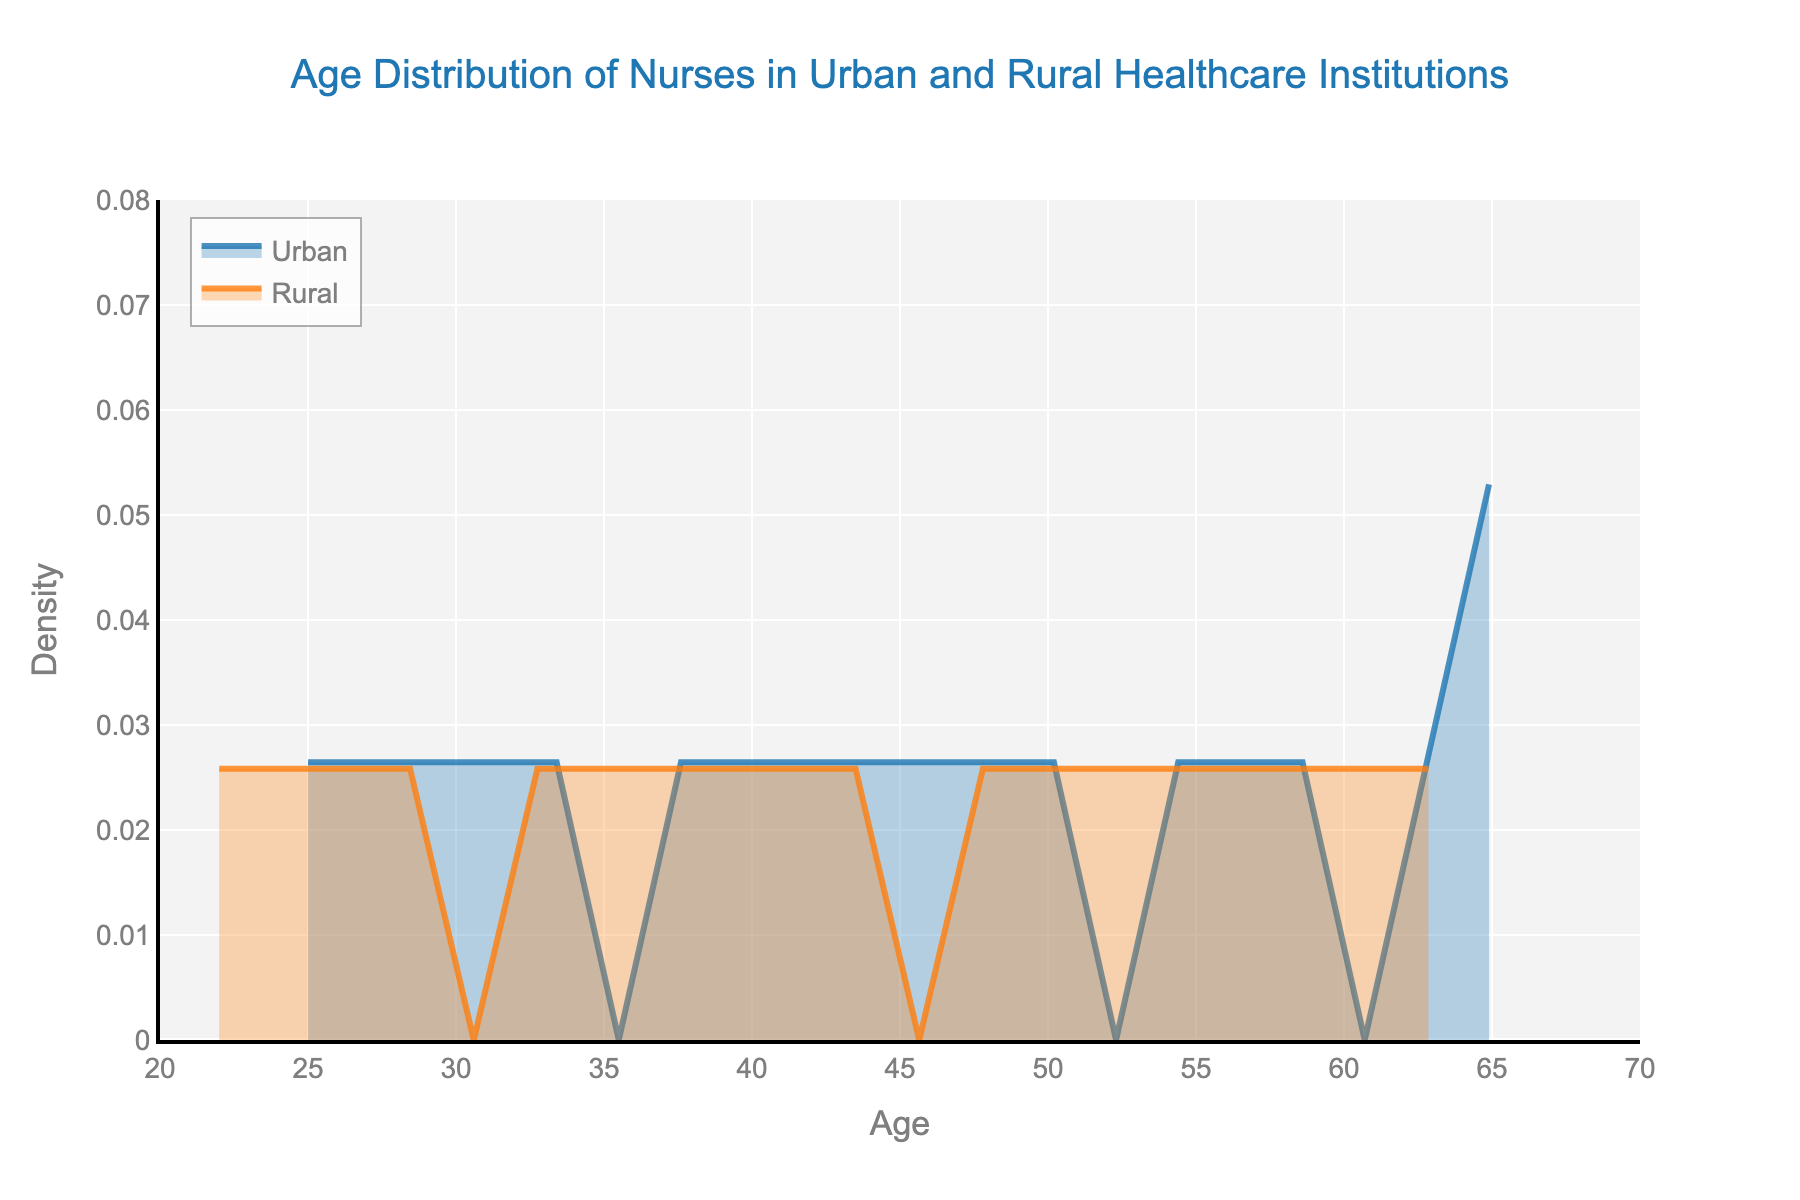What's the title of the figure? The title is usually found at the top of the figure. In this case, it reads "Age Distribution of Nurses in Urban and Rural Healthcare Institutions."
Answer: Age Distribution of Nurses in Urban and Rural Healthcare Institutions What is the range of ages displayed on the x-axis of the figure? The age range on the x-axis is specified by the axis ticks. Here, it ranges from 20 to 70 years.
Answer: 20 to 70 years What age group has the most density among urban nurses? The peak of the density plot for urban nurses indicates the age group with the highest density. This peak is around the 40-45 age range.
Answer: 40-45 years Which location has the wider age range in the plot? To determine the wider age range, observe the horizontal spread of the density plots for both locations. In this case, the urban nurses' age plot starts at 25 and extends to 67, while the rural nurses' age plot ranges from 22 to 65. Urban has a slightly wider range.
Answer: Urban At what age do rural nurses' density reach its maximum? The peak of the density plot for rural nurses shows the age with the highest density. This peak is around the 30-35 age range.
Answer: 30-35 years How does the density of nurses aged 50 differ between urban and rural locations? To compare densities at age 50, locate this age on the x-axis and observe the densities for both lines. The urban density is slightly higher than the rural density at age 50.
Answer: Urban slightly higher Are there more younger nurses (below age 40) in rural areas compared to urban areas? Compare the density plots to see which has a higher density below age 40. The density plot for rural areas is higher than urban areas below age 40, indicating more younger nurses in rural areas.
Answer: Yes What can you infer about the distribution of older nurses (above age 60) between urban and rural locations? By examining the density plots, we see that the density of urban nurses above age 60 is slightly higher than rural nurses, indicating more older nurses in urban areas.
Answer: Urban has more older nurses Are there any ages where the density of urban and rural nurses are approximately equal? To find where the densities are equal, look for points where both density plots intersect. They approximately intersect around 30 and 45 years.
Answer: Around 30 and 45 years Which location has a more uniform age distribution? A more uniform distribution would have a flatter density plot over a range of ages. The urban density plot appears flatter compared to the rural plot, indicating a more uniform age distribution.
Answer: Urban 